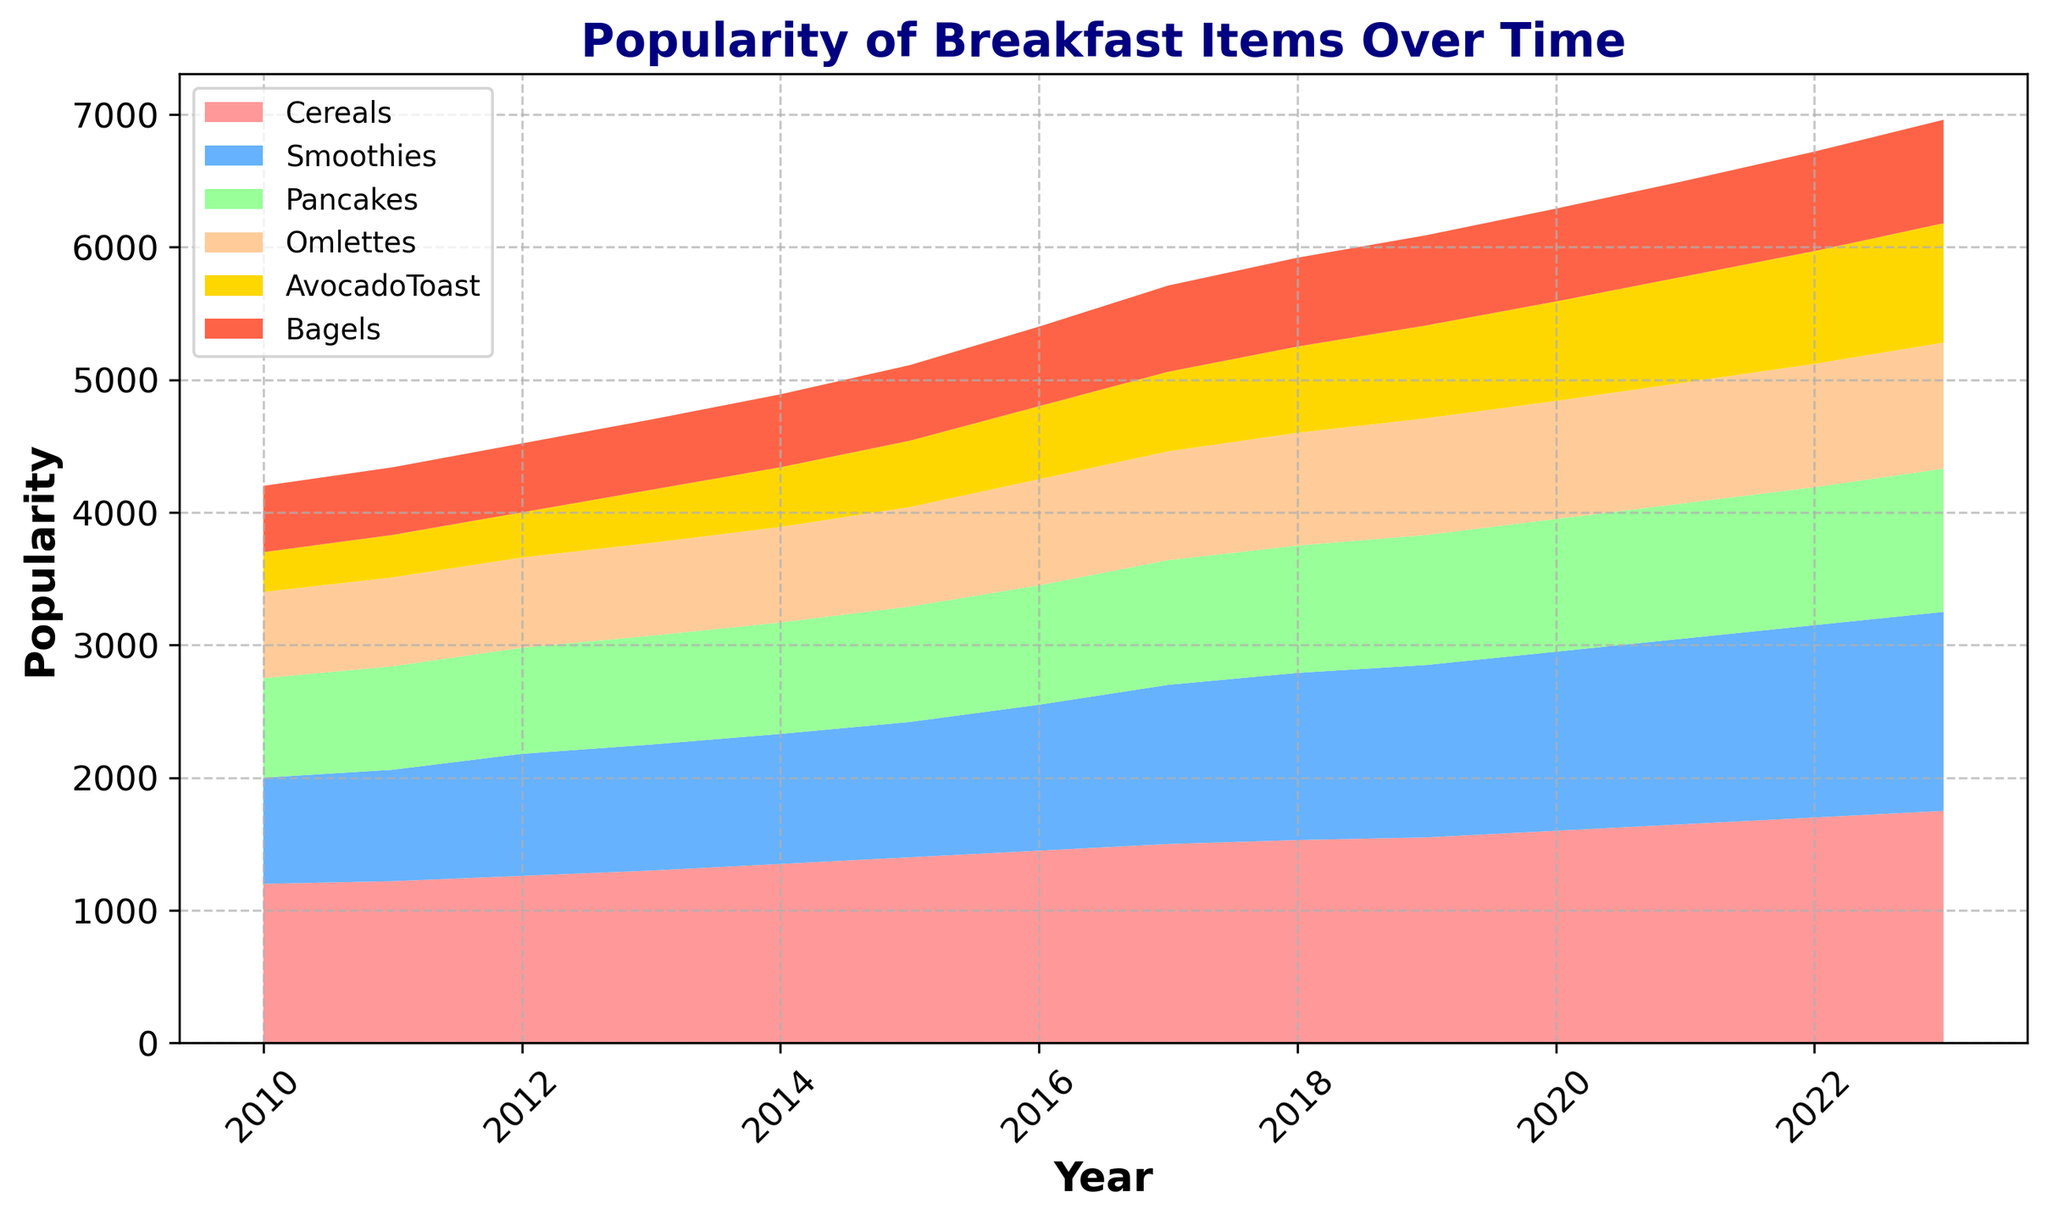What is the most popular breakfast item in 2023? In 2023, the item with the highest popularity value is Cereals with a value of 1750.
Answer: Cereals Which breakfast item showed the most consistent growth over the years? Avocado Toast shows consistent growth without any declines or plateaus from 2010 to 2023, increasing each year.
Answer: Avocado Toast How much did the popularity of Smoothies increase from 2010 to 2023? The popularity of Smoothies in 2010 was 800. In 2023, it is 1500. The increase is 1500 - 800 = 700.
Answer: 700 Compare the popularity of Pancakes and Omlettes in 2020. Which one was more popular? In 2020, the popularity of Pancakes was 1000, while Omlettes had a popularity of 890. Pancakes were more popular.
Answer: Pancakes What is the sum of the popularity values of Bagels and Avocado Toast in 2019? In 2019, the popularity of Bagels was 680 and Avocado Toast was 700. The sum is 680 + 700 = 1380.
Answer: 1380 Which year experienced the highest increase in the popularity of Bagels compared to its previous year? From 2016 to 2017, the popularity of Bagels increased from 600 to 650, which is an increase of 50, higher than any other year-to-year increase.
Answer: 2017 By how much did the popularity of Omelettes change from 2011 to 2015? In 2011, the popularity of Omelettes was 670 and in 2015 it was 750. The change is 750 - 670 = 80.
Answer: 80 Which breakfast item saw a decrease in popularity at any time point or stayed even throughout the period shown? None of the items in the chart experienced a decrease or even stayed at the same value; each item showed an increasing trend over the time period.
Answer: None What is the difference in popularity between Smoothies and Bagels in 2018? In 2018, Smoothies had a popularity value of 1260 and Bagels had 670. The difference is 1260 - 670 = 590.
Answer: 590 Which breakfast items experienced a steady increase in popularity every year without any decline? Avocado Toast and Bagels both experienced a steady increase in popularity every year without any decline.
Answer: Avocado Toast, Bagels 